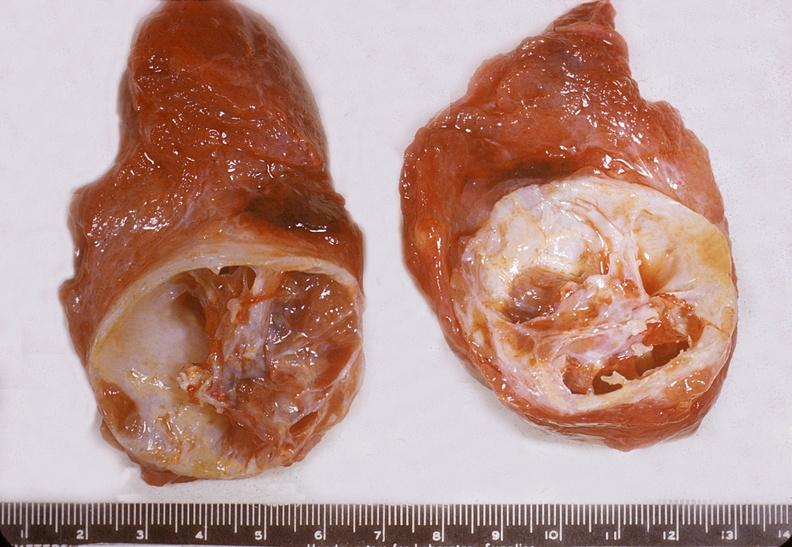s endocrine present?
Answer the question using a single word or phrase. Yes 